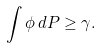<formula> <loc_0><loc_0><loc_500><loc_500>\int \phi \, d P \geq \gamma .</formula> 